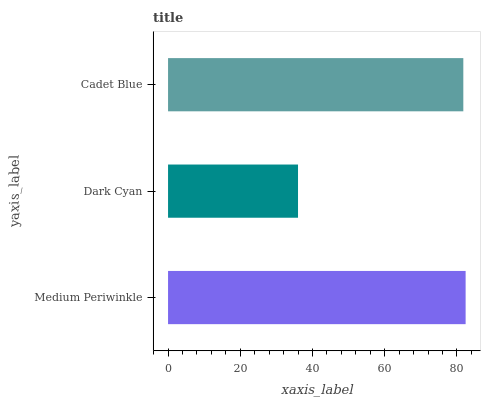Is Dark Cyan the minimum?
Answer yes or no. Yes. Is Medium Periwinkle the maximum?
Answer yes or no. Yes. Is Cadet Blue the minimum?
Answer yes or no. No. Is Cadet Blue the maximum?
Answer yes or no. No. Is Cadet Blue greater than Dark Cyan?
Answer yes or no. Yes. Is Dark Cyan less than Cadet Blue?
Answer yes or no. Yes. Is Dark Cyan greater than Cadet Blue?
Answer yes or no. No. Is Cadet Blue less than Dark Cyan?
Answer yes or no. No. Is Cadet Blue the high median?
Answer yes or no. Yes. Is Cadet Blue the low median?
Answer yes or no. Yes. Is Dark Cyan the high median?
Answer yes or no. No. Is Dark Cyan the low median?
Answer yes or no. No. 